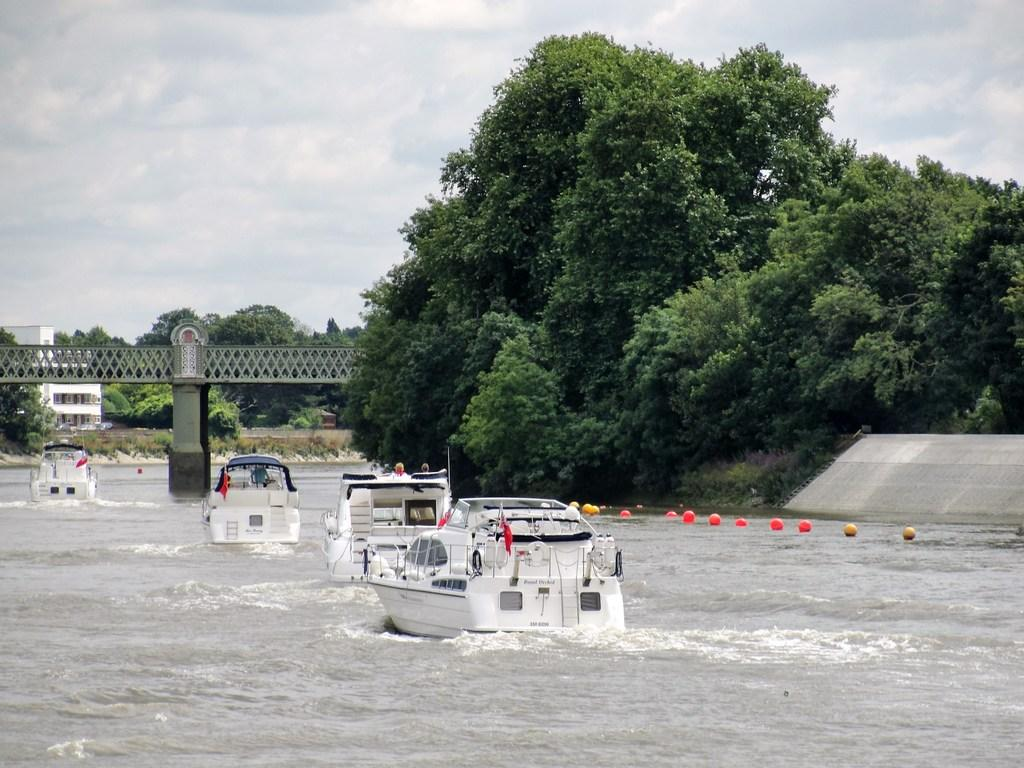What is happening in the image? There are boats on water in the image, and people are visible. What structures can be seen in the image? There is a bridge and a building in the image. What can be seen in the background of the image? There are trees and the sky visible in the background. What else is present in the image? There are objects in the image. Where is the cave located in the image? There is no cave present in the image. What type of cork is used to seal the boats in the image? There are no corks mentioned or visible in the image. 